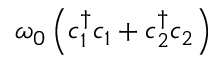Convert formula to latex. <formula><loc_0><loc_0><loc_500><loc_500>\omega _ { 0 } \left ( c _ { 1 } ^ { \dagger } c _ { 1 } + c _ { 2 } ^ { \dagger } c _ { 2 } \right )</formula> 